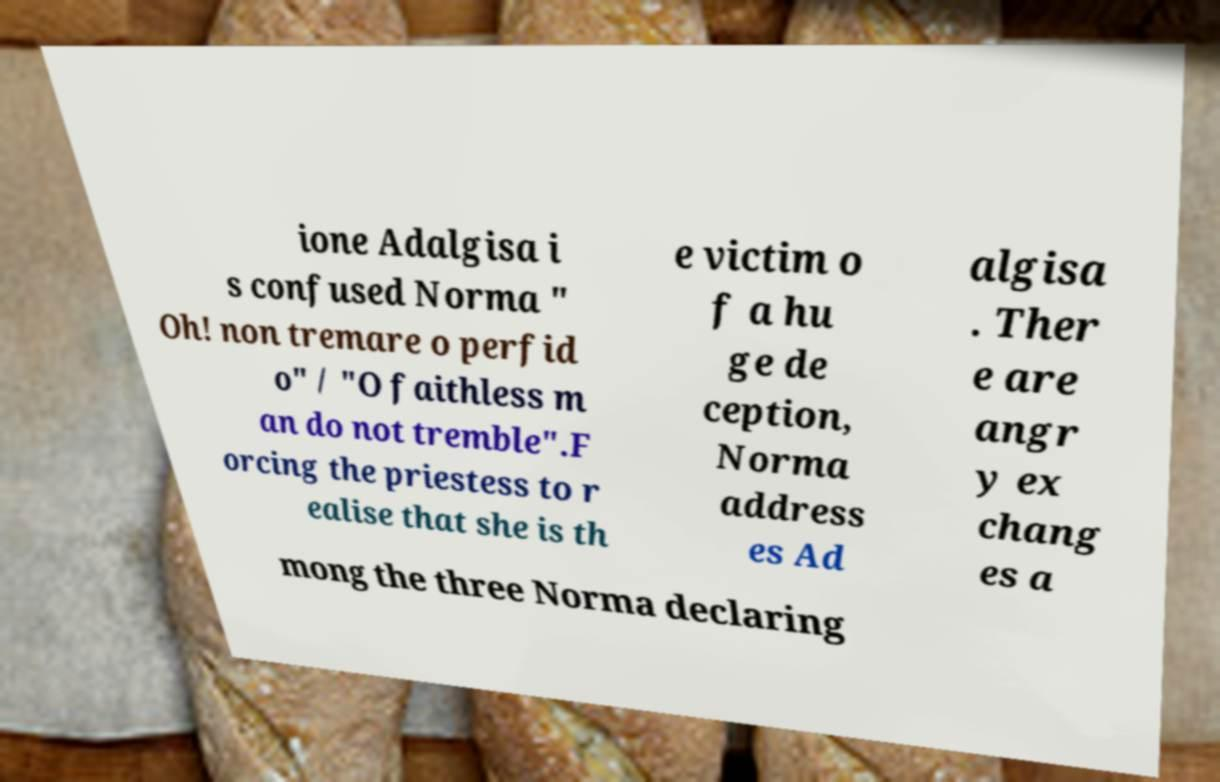Could you assist in decoding the text presented in this image and type it out clearly? ione Adalgisa i s confused Norma " Oh! non tremare o perfid o" / "O faithless m an do not tremble".F orcing the priestess to r ealise that she is th e victim o f a hu ge de ception, Norma address es Ad algisa . Ther e are angr y ex chang es a mong the three Norma declaring 